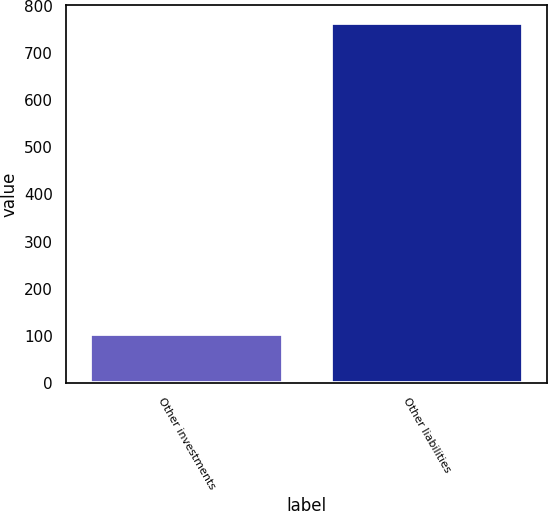Convert chart. <chart><loc_0><loc_0><loc_500><loc_500><bar_chart><fcel>Other investments<fcel>Other liabilities<nl><fcel>103<fcel>763<nl></chart> 